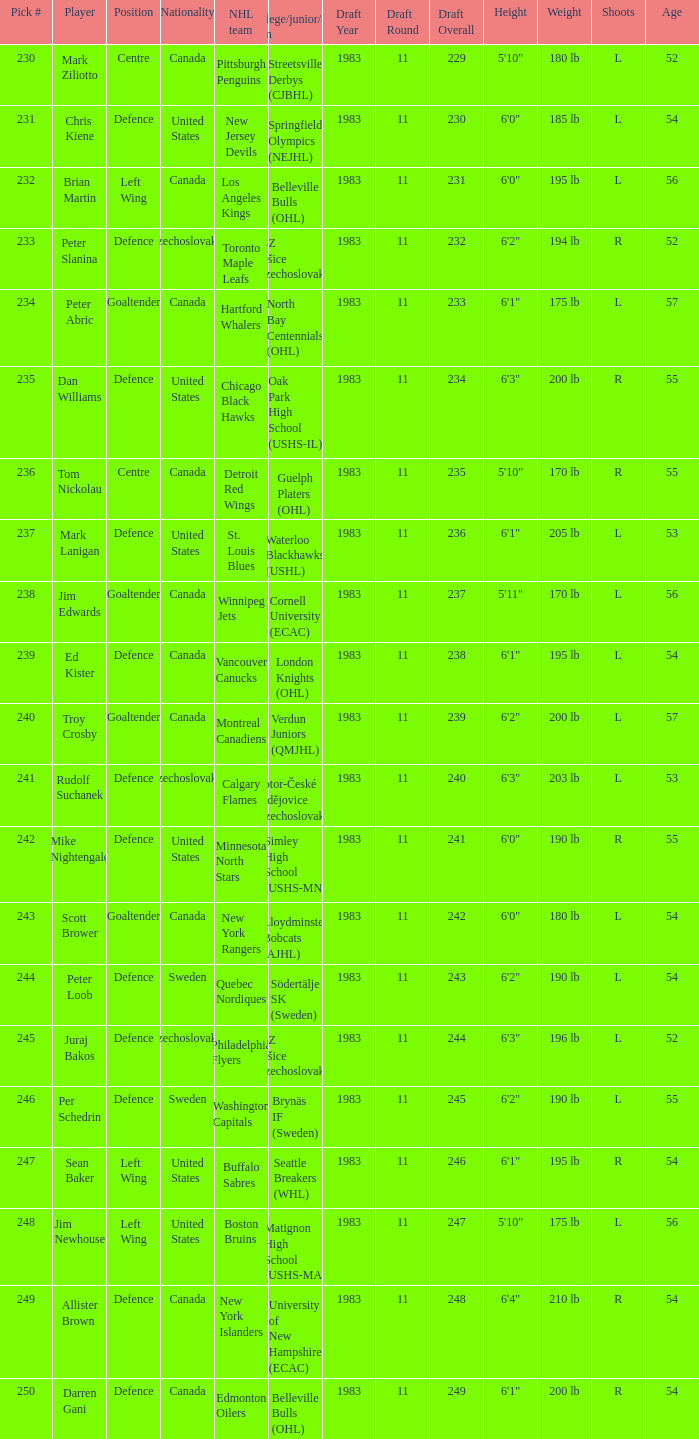What position does allister brown play. Defence. 